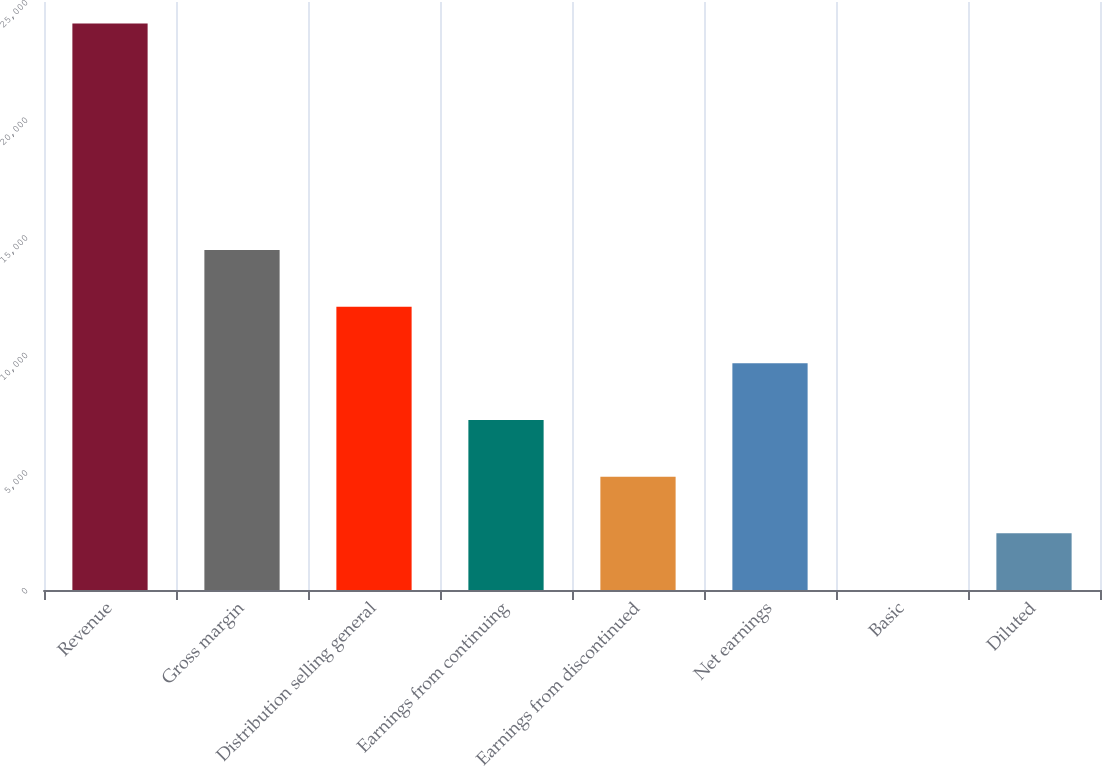Convert chart. <chart><loc_0><loc_0><loc_500><loc_500><bar_chart><fcel>Revenue<fcel>Gross margin<fcel>Distribution selling general<fcel>Earnings from continuing<fcel>Earnings from discontinued<fcel>Net earnings<fcel>Basic<fcel>Diluted<nl><fcel>24089.3<fcel>14453.8<fcel>12045<fcel>7227.21<fcel>4818.34<fcel>9636.08<fcel>0.6<fcel>2409.47<nl></chart> 